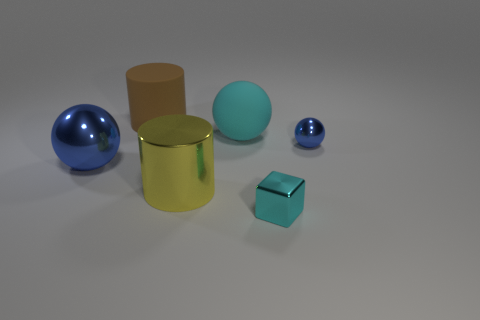How many blue metal balls are the same size as the yellow shiny cylinder?
Offer a very short reply. 1. How many red objects are large cylinders or large metallic cubes?
Offer a terse response. 0. Are there an equal number of metallic spheres that are right of the large brown object and big blue matte blocks?
Offer a terse response. No. What is the size of the cylinder behind the shiny cylinder?
Your answer should be compact. Large. How many other large shiny objects are the same shape as the brown object?
Offer a very short reply. 1. What is the thing that is right of the large metallic cylinder and on the left side of the tiny cyan object made of?
Make the answer very short. Rubber. Does the yellow cylinder have the same material as the big brown cylinder?
Give a very brief answer. No. What number of small objects are there?
Provide a short and direct response. 2. There is a large cylinder that is on the left side of the cylinder in front of the large blue shiny sphere that is behind the tiny cyan metal object; what color is it?
Provide a succinct answer. Brown. Do the big metal cylinder and the small block have the same color?
Provide a succinct answer. No. 